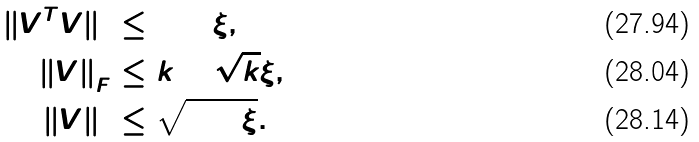Convert formula to latex. <formula><loc_0><loc_0><loc_500><loc_500>\| \hat { V } ^ { T } \hat { V } \| _ { 2 } & \leq 1 + \xi , \\ \| \hat { V } \| ^ { 2 } _ { F } & \leq k + \sqrt { k } \xi , \\ \| \hat { V } \| _ { 2 } & \leq \sqrt { 1 + \xi } .</formula> 